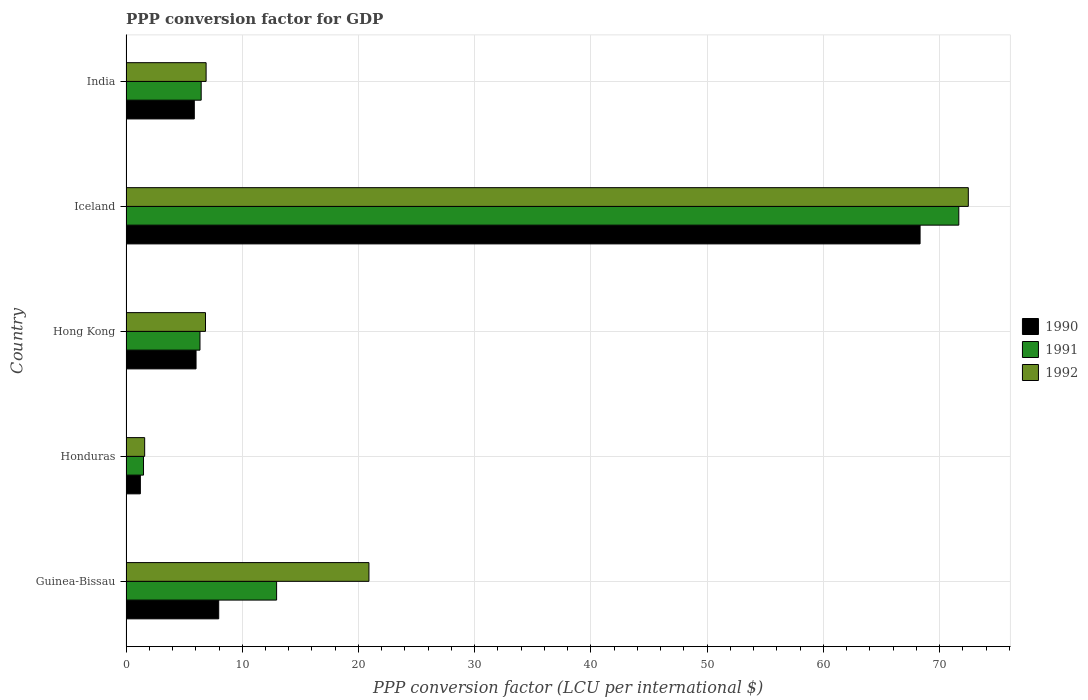How many groups of bars are there?
Provide a succinct answer. 5. Are the number of bars on each tick of the Y-axis equal?
Keep it short and to the point. Yes. What is the label of the 2nd group of bars from the top?
Your answer should be very brief. Iceland. In how many cases, is the number of bars for a given country not equal to the number of legend labels?
Your answer should be compact. 0. What is the PPP conversion factor for GDP in 1990 in Honduras?
Keep it short and to the point. 1.23. Across all countries, what is the maximum PPP conversion factor for GDP in 1991?
Offer a terse response. 71.65. Across all countries, what is the minimum PPP conversion factor for GDP in 1991?
Provide a succinct answer. 1.51. In which country was the PPP conversion factor for GDP in 1991 maximum?
Ensure brevity in your answer.  Iceland. In which country was the PPP conversion factor for GDP in 1990 minimum?
Provide a succinct answer. Honduras. What is the total PPP conversion factor for GDP in 1991 in the graph?
Offer a very short reply. 98.95. What is the difference between the PPP conversion factor for GDP in 1990 in Guinea-Bissau and that in Hong Kong?
Offer a terse response. 1.95. What is the difference between the PPP conversion factor for GDP in 1990 in Hong Kong and the PPP conversion factor for GDP in 1991 in Guinea-Bissau?
Your response must be concise. -6.93. What is the average PPP conversion factor for GDP in 1990 per country?
Offer a terse response. 17.89. What is the difference between the PPP conversion factor for GDP in 1990 and PPP conversion factor for GDP in 1991 in Iceland?
Keep it short and to the point. -3.33. What is the ratio of the PPP conversion factor for GDP in 1992 in Hong Kong to that in Iceland?
Give a very brief answer. 0.09. Is the PPP conversion factor for GDP in 1990 in Hong Kong less than that in India?
Give a very brief answer. No. Is the difference between the PPP conversion factor for GDP in 1990 in Guinea-Bissau and Honduras greater than the difference between the PPP conversion factor for GDP in 1991 in Guinea-Bissau and Honduras?
Ensure brevity in your answer.  No. What is the difference between the highest and the second highest PPP conversion factor for GDP in 1992?
Ensure brevity in your answer.  51.57. What is the difference between the highest and the lowest PPP conversion factor for GDP in 1990?
Keep it short and to the point. 67.09. In how many countries, is the PPP conversion factor for GDP in 1991 greater than the average PPP conversion factor for GDP in 1991 taken over all countries?
Provide a short and direct response. 1. What does the 2nd bar from the top in Hong Kong represents?
Your answer should be very brief. 1991. What does the 2nd bar from the bottom in Guinea-Bissau represents?
Your answer should be compact. 1991. Is it the case that in every country, the sum of the PPP conversion factor for GDP in 1991 and PPP conversion factor for GDP in 1992 is greater than the PPP conversion factor for GDP in 1990?
Ensure brevity in your answer.  Yes. How many legend labels are there?
Offer a very short reply. 3. How are the legend labels stacked?
Your answer should be very brief. Vertical. What is the title of the graph?
Offer a very short reply. PPP conversion factor for GDP. Does "1989" appear as one of the legend labels in the graph?
Ensure brevity in your answer.  No. What is the label or title of the X-axis?
Offer a very short reply. PPP conversion factor (LCU per international $). What is the PPP conversion factor (LCU per international $) in 1990 in Guinea-Bissau?
Your answer should be compact. 7.97. What is the PPP conversion factor (LCU per international $) of 1991 in Guinea-Bissau?
Offer a terse response. 12.96. What is the PPP conversion factor (LCU per international $) of 1992 in Guinea-Bissau?
Your response must be concise. 20.9. What is the PPP conversion factor (LCU per international $) of 1990 in Honduras?
Offer a terse response. 1.23. What is the PPP conversion factor (LCU per international $) in 1991 in Honduras?
Offer a very short reply. 1.51. What is the PPP conversion factor (LCU per international $) of 1992 in Honduras?
Your response must be concise. 1.61. What is the PPP conversion factor (LCU per international $) of 1990 in Hong Kong?
Give a very brief answer. 6.03. What is the PPP conversion factor (LCU per international $) of 1991 in Hong Kong?
Offer a terse response. 6.36. What is the PPP conversion factor (LCU per international $) in 1992 in Hong Kong?
Ensure brevity in your answer.  6.84. What is the PPP conversion factor (LCU per international $) in 1990 in Iceland?
Provide a succinct answer. 68.32. What is the PPP conversion factor (LCU per international $) of 1991 in Iceland?
Make the answer very short. 71.65. What is the PPP conversion factor (LCU per international $) of 1992 in Iceland?
Provide a short and direct response. 72.47. What is the PPP conversion factor (LCU per international $) in 1990 in India?
Offer a terse response. 5.88. What is the PPP conversion factor (LCU per international $) in 1991 in India?
Offer a terse response. 6.47. What is the PPP conversion factor (LCU per international $) of 1992 in India?
Give a very brief answer. 6.89. Across all countries, what is the maximum PPP conversion factor (LCU per international $) of 1990?
Offer a very short reply. 68.32. Across all countries, what is the maximum PPP conversion factor (LCU per international $) of 1991?
Offer a very short reply. 71.65. Across all countries, what is the maximum PPP conversion factor (LCU per international $) in 1992?
Offer a very short reply. 72.47. Across all countries, what is the minimum PPP conversion factor (LCU per international $) in 1990?
Keep it short and to the point. 1.23. Across all countries, what is the minimum PPP conversion factor (LCU per international $) of 1991?
Keep it short and to the point. 1.51. Across all countries, what is the minimum PPP conversion factor (LCU per international $) of 1992?
Keep it short and to the point. 1.61. What is the total PPP conversion factor (LCU per international $) in 1990 in the graph?
Keep it short and to the point. 89.43. What is the total PPP conversion factor (LCU per international $) in 1991 in the graph?
Provide a succinct answer. 98.95. What is the total PPP conversion factor (LCU per international $) in 1992 in the graph?
Your response must be concise. 108.71. What is the difference between the PPP conversion factor (LCU per international $) of 1990 in Guinea-Bissau and that in Honduras?
Keep it short and to the point. 6.74. What is the difference between the PPP conversion factor (LCU per international $) of 1991 in Guinea-Bissau and that in Honduras?
Your answer should be very brief. 11.45. What is the difference between the PPP conversion factor (LCU per international $) in 1992 in Guinea-Bissau and that in Honduras?
Give a very brief answer. 19.3. What is the difference between the PPP conversion factor (LCU per international $) of 1990 in Guinea-Bissau and that in Hong Kong?
Provide a succinct answer. 1.95. What is the difference between the PPP conversion factor (LCU per international $) of 1991 in Guinea-Bissau and that in Hong Kong?
Keep it short and to the point. 6.59. What is the difference between the PPP conversion factor (LCU per international $) in 1992 in Guinea-Bissau and that in Hong Kong?
Make the answer very short. 14.06. What is the difference between the PPP conversion factor (LCU per international $) of 1990 in Guinea-Bissau and that in Iceland?
Make the answer very short. -60.35. What is the difference between the PPP conversion factor (LCU per international $) of 1991 in Guinea-Bissau and that in Iceland?
Ensure brevity in your answer.  -58.69. What is the difference between the PPP conversion factor (LCU per international $) of 1992 in Guinea-Bissau and that in Iceland?
Your response must be concise. -51.57. What is the difference between the PPP conversion factor (LCU per international $) of 1990 in Guinea-Bissau and that in India?
Your response must be concise. 2.1. What is the difference between the PPP conversion factor (LCU per international $) of 1991 in Guinea-Bissau and that in India?
Offer a very short reply. 6.49. What is the difference between the PPP conversion factor (LCU per international $) of 1992 in Guinea-Bissau and that in India?
Offer a terse response. 14.01. What is the difference between the PPP conversion factor (LCU per international $) in 1990 in Honduras and that in Hong Kong?
Provide a short and direct response. -4.79. What is the difference between the PPP conversion factor (LCU per international $) in 1991 in Honduras and that in Hong Kong?
Your response must be concise. -4.86. What is the difference between the PPP conversion factor (LCU per international $) in 1992 in Honduras and that in Hong Kong?
Offer a terse response. -5.23. What is the difference between the PPP conversion factor (LCU per international $) in 1990 in Honduras and that in Iceland?
Provide a succinct answer. -67.09. What is the difference between the PPP conversion factor (LCU per international $) of 1991 in Honduras and that in Iceland?
Your answer should be very brief. -70.15. What is the difference between the PPP conversion factor (LCU per international $) of 1992 in Honduras and that in Iceland?
Ensure brevity in your answer.  -70.86. What is the difference between the PPP conversion factor (LCU per international $) in 1990 in Honduras and that in India?
Make the answer very short. -4.64. What is the difference between the PPP conversion factor (LCU per international $) in 1991 in Honduras and that in India?
Offer a terse response. -4.96. What is the difference between the PPP conversion factor (LCU per international $) in 1992 in Honduras and that in India?
Your answer should be very brief. -5.29. What is the difference between the PPP conversion factor (LCU per international $) in 1990 in Hong Kong and that in Iceland?
Ensure brevity in your answer.  -62.3. What is the difference between the PPP conversion factor (LCU per international $) of 1991 in Hong Kong and that in Iceland?
Ensure brevity in your answer.  -65.29. What is the difference between the PPP conversion factor (LCU per international $) of 1992 in Hong Kong and that in Iceland?
Provide a succinct answer. -65.63. What is the difference between the PPP conversion factor (LCU per international $) of 1990 in Hong Kong and that in India?
Provide a succinct answer. 0.15. What is the difference between the PPP conversion factor (LCU per international $) of 1991 in Hong Kong and that in India?
Provide a short and direct response. -0.1. What is the difference between the PPP conversion factor (LCU per international $) in 1992 in Hong Kong and that in India?
Your answer should be compact. -0.05. What is the difference between the PPP conversion factor (LCU per international $) in 1990 in Iceland and that in India?
Your answer should be very brief. 62.45. What is the difference between the PPP conversion factor (LCU per international $) in 1991 in Iceland and that in India?
Give a very brief answer. 65.18. What is the difference between the PPP conversion factor (LCU per international $) in 1992 in Iceland and that in India?
Provide a short and direct response. 65.58. What is the difference between the PPP conversion factor (LCU per international $) of 1990 in Guinea-Bissau and the PPP conversion factor (LCU per international $) of 1991 in Honduras?
Offer a terse response. 6.47. What is the difference between the PPP conversion factor (LCU per international $) in 1990 in Guinea-Bissau and the PPP conversion factor (LCU per international $) in 1992 in Honduras?
Provide a short and direct response. 6.37. What is the difference between the PPP conversion factor (LCU per international $) of 1991 in Guinea-Bissau and the PPP conversion factor (LCU per international $) of 1992 in Honduras?
Offer a very short reply. 11.35. What is the difference between the PPP conversion factor (LCU per international $) in 1990 in Guinea-Bissau and the PPP conversion factor (LCU per international $) in 1991 in Hong Kong?
Keep it short and to the point. 1.61. What is the difference between the PPP conversion factor (LCU per international $) in 1990 in Guinea-Bissau and the PPP conversion factor (LCU per international $) in 1992 in Hong Kong?
Offer a very short reply. 1.14. What is the difference between the PPP conversion factor (LCU per international $) in 1991 in Guinea-Bissau and the PPP conversion factor (LCU per international $) in 1992 in Hong Kong?
Offer a terse response. 6.12. What is the difference between the PPP conversion factor (LCU per international $) of 1990 in Guinea-Bissau and the PPP conversion factor (LCU per international $) of 1991 in Iceland?
Give a very brief answer. -63.68. What is the difference between the PPP conversion factor (LCU per international $) in 1990 in Guinea-Bissau and the PPP conversion factor (LCU per international $) in 1992 in Iceland?
Offer a very short reply. -64.5. What is the difference between the PPP conversion factor (LCU per international $) in 1991 in Guinea-Bissau and the PPP conversion factor (LCU per international $) in 1992 in Iceland?
Ensure brevity in your answer.  -59.51. What is the difference between the PPP conversion factor (LCU per international $) of 1990 in Guinea-Bissau and the PPP conversion factor (LCU per international $) of 1991 in India?
Offer a terse response. 1.51. What is the difference between the PPP conversion factor (LCU per international $) in 1990 in Guinea-Bissau and the PPP conversion factor (LCU per international $) in 1992 in India?
Offer a very short reply. 1.08. What is the difference between the PPP conversion factor (LCU per international $) of 1991 in Guinea-Bissau and the PPP conversion factor (LCU per international $) of 1992 in India?
Your response must be concise. 6.07. What is the difference between the PPP conversion factor (LCU per international $) in 1990 in Honduras and the PPP conversion factor (LCU per international $) in 1991 in Hong Kong?
Keep it short and to the point. -5.13. What is the difference between the PPP conversion factor (LCU per international $) of 1990 in Honduras and the PPP conversion factor (LCU per international $) of 1992 in Hong Kong?
Give a very brief answer. -5.6. What is the difference between the PPP conversion factor (LCU per international $) in 1991 in Honduras and the PPP conversion factor (LCU per international $) in 1992 in Hong Kong?
Your response must be concise. -5.33. What is the difference between the PPP conversion factor (LCU per international $) of 1990 in Honduras and the PPP conversion factor (LCU per international $) of 1991 in Iceland?
Make the answer very short. -70.42. What is the difference between the PPP conversion factor (LCU per international $) in 1990 in Honduras and the PPP conversion factor (LCU per international $) in 1992 in Iceland?
Your response must be concise. -71.24. What is the difference between the PPP conversion factor (LCU per international $) in 1991 in Honduras and the PPP conversion factor (LCU per international $) in 1992 in Iceland?
Provide a succinct answer. -70.97. What is the difference between the PPP conversion factor (LCU per international $) in 1990 in Honduras and the PPP conversion factor (LCU per international $) in 1991 in India?
Offer a terse response. -5.23. What is the difference between the PPP conversion factor (LCU per international $) of 1990 in Honduras and the PPP conversion factor (LCU per international $) of 1992 in India?
Offer a very short reply. -5.66. What is the difference between the PPP conversion factor (LCU per international $) in 1991 in Honduras and the PPP conversion factor (LCU per international $) in 1992 in India?
Your answer should be compact. -5.39. What is the difference between the PPP conversion factor (LCU per international $) of 1990 in Hong Kong and the PPP conversion factor (LCU per international $) of 1991 in Iceland?
Provide a succinct answer. -65.63. What is the difference between the PPP conversion factor (LCU per international $) of 1990 in Hong Kong and the PPP conversion factor (LCU per international $) of 1992 in Iceland?
Make the answer very short. -66.44. What is the difference between the PPP conversion factor (LCU per international $) of 1991 in Hong Kong and the PPP conversion factor (LCU per international $) of 1992 in Iceland?
Provide a short and direct response. -66.11. What is the difference between the PPP conversion factor (LCU per international $) of 1990 in Hong Kong and the PPP conversion factor (LCU per international $) of 1991 in India?
Offer a terse response. -0.44. What is the difference between the PPP conversion factor (LCU per international $) of 1990 in Hong Kong and the PPP conversion factor (LCU per international $) of 1992 in India?
Make the answer very short. -0.87. What is the difference between the PPP conversion factor (LCU per international $) of 1991 in Hong Kong and the PPP conversion factor (LCU per international $) of 1992 in India?
Give a very brief answer. -0.53. What is the difference between the PPP conversion factor (LCU per international $) of 1990 in Iceland and the PPP conversion factor (LCU per international $) of 1991 in India?
Ensure brevity in your answer.  61.85. What is the difference between the PPP conversion factor (LCU per international $) in 1990 in Iceland and the PPP conversion factor (LCU per international $) in 1992 in India?
Your answer should be very brief. 61.43. What is the difference between the PPP conversion factor (LCU per international $) of 1991 in Iceland and the PPP conversion factor (LCU per international $) of 1992 in India?
Give a very brief answer. 64.76. What is the average PPP conversion factor (LCU per international $) in 1990 per country?
Your response must be concise. 17.89. What is the average PPP conversion factor (LCU per international $) of 1991 per country?
Provide a short and direct response. 19.79. What is the average PPP conversion factor (LCU per international $) in 1992 per country?
Your answer should be compact. 21.74. What is the difference between the PPP conversion factor (LCU per international $) of 1990 and PPP conversion factor (LCU per international $) of 1991 in Guinea-Bissau?
Your response must be concise. -4.98. What is the difference between the PPP conversion factor (LCU per international $) of 1990 and PPP conversion factor (LCU per international $) of 1992 in Guinea-Bissau?
Make the answer very short. -12.93. What is the difference between the PPP conversion factor (LCU per international $) of 1991 and PPP conversion factor (LCU per international $) of 1992 in Guinea-Bissau?
Provide a succinct answer. -7.94. What is the difference between the PPP conversion factor (LCU per international $) in 1990 and PPP conversion factor (LCU per international $) in 1991 in Honduras?
Offer a very short reply. -0.27. What is the difference between the PPP conversion factor (LCU per international $) in 1990 and PPP conversion factor (LCU per international $) in 1992 in Honduras?
Provide a short and direct response. -0.37. What is the difference between the PPP conversion factor (LCU per international $) in 1991 and PPP conversion factor (LCU per international $) in 1992 in Honduras?
Give a very brief answer. -0.1. What is the difference between the PPP conversion factor (LCU per international $) of 1990 and PPP conversion factor (LCU per international $) of 1991 in Hong Kong?
Ensure brevity in your answer.  -0.34. What is the difference between the PPP conversion factor (LCU per international $) in 1990 and PPP conversion factor (LCU per international $) in 1992 in Hong Kong?
Keep it short and to the point. -0.81. What is the difference between the PPP conversion factor (LCU per international $) in 1991 and PPP conversion factor (LCU per international $) in 1992 in Hong Kong?
Your answer should be compact. -0.47. What is the difference between the PPP conversion factor (LCU per international $) in 1990 and PPP conversion factor (LCU per international $) in 1991 in Iceland?
Offer a terse response. -3.33. What is the difference between the PPP conversion factor (LCU per international $) in 1990 and PPP conversion factor (LCU per international $) in 1992 in Iceland?
Ensure brevity in your answer.  -4.15. What is the difference between the PPP conversion factor (LCU per international $) of 1991 and PPP conversion factor (LCU per international $) of 1992 in Iceland?
Offer a terse response. -0.82. What is the difference between the PPP conversion factor (LCU per international $) of 1990 and PPP conversion factor (LCU per international $) of 1991 in India?
Offer a very short reply. -0.59. What is the difference between the PPP conversion factor (LCU per international $) in 1990 and PPP conversion factor (LCU per international $) in 1992 in India?
Your answer should be compact. -1.02. What is the difference between the PPP conversion factor (LCU per international $) of 1991 and PPP conversion factor (LCU per international $) of 1992 in India?
Offer a very short reply. -0.42. What is the ratio of the PPP conversion factor (LCU per international $) of 1990 in Guinea-Bissau to that in Honduras?
Offer a very short reply. 6.46. What is the ratio of the PPP conversion factor (LCU per international $) in 1991 in Guinea-Bissau to that in Honduras?
Offer a terse response. 8.61. What is the ratio of the PPP conversion factor (LCU per international $) in 1992 in Guinea-Bissau to that in Honduras?
Keep it short and to the point. 13.02. What is the ratio of the PPP conversion factor (LCU per international $) in 1990 in Guinea-Bissau to that in Hong Kong?
Offer a terse response. 1.32. What is the ratio of the PPP conversion factor (LCU per international $) of 1991 in Guinea-Bissau to that in Hong Kong?
Your response must be concise. 2.04. What is the ratio of the PPP conversion factor (LCU per international $) of 1992 in Guinea-Bissau to that in Hong Kong?
Offer a very short reply. 3.06. What is the ratio of the PPP conversion factor (LCU per international $) in 1990 in Guinea-Bissau to that in Iceland?
Your answer should be compact. 0.12. What is the ratio of the PPP conversion factor (LCU per international $) of 1991 in Guinea-Bissau to that in Iceland?
Make the answer very short. 0.18. What is the ratio of the PPP conversion factor (LCU per international $) in 1992 in Guinea-Bissau to that in Iceland?
Offer a terse response. 0.29. What is the ratio of the PPP conversion factor (LCU per international $) in 1990 in Guinea-Bissau to that in India?
Your response must be concise. 1.36. What is the ratio of the PPP conversion factor (LCU per international $) in 1991 in Guinea-Bissau to that in India?
Ensure brevity in your answer.  2. What is the ratio of the PPP conversion factor (LCU per international $) of 1992 in Guinea-Bissau to that in India?
Make the answer very short. 3.03. What is the ratio of the PPP conversion factor (LCU per international $) in 1990 in Honduras to that in Hong Kong?
Provide a succinct answer. 0.2. What is the ratio of the PPP conversion factor (LCU per international $) in 1991 in Honduras to that in Hong Kong?
Provide a succinct answer. 0.24. What is the ratio of the PPP conversion factor (LCU per international $) of 1992 in Honduras to that in Hong Kong?
Provide a short and direct response. 0.23. What is the ratio of the PPP conversion factor (LCU per international $) of 1990 in Honduras to that in Iceland?
Offer a terse response. 0.02. What is the ratio of the PPP conversion factor (LCU per international $) in 1991 in Honduras to that in Iceland?
Make the answer very short. 0.02. What is the ratio of the PPP conversion factor (LCU per international $) of 1992 in Honduras to that in Iceland?
Your answer should be compact. 0.02. What is the ratio of the PPP conversion factor (LCU per international $) in 1990 in Honduras to that in India?
Ensure brevity in your answer.  0.21. What is the ratio of the PPP conversion factor (LCU per international $) of 1991 in Honduras to that in India?
Your response must be concise. 0.23. What is the ratio of the PPP conversion factor (LCU per international $) of 1992 in Honduras to that in India?
Offer a terse response. 0.23. What is the ratio of the PPP conversion factor (LCU per international $) in 1990 in Hong Kong to that in Iceland?
Offer a terse response. 0.09. What is the ratio of the PPP conversion factor (LCU per international $) in 1991 in Hong Kong to that in Iceland?
Offer a very short reply. 0.09. What is the ratio of the PPP conversion factor (LCU per international $) in 1992 in Hong Kong to that in Iceland?
Keep it short and to the point. 0.09. What is the ratio of the PPP conversion factor (LCU per international $) of 1990 in Hong Kong to that in India?
Your response must be concise. 1.03. What is the ratio of the PPP conversion factor (LCU per international $) in 1992 in Hong Kong to that in India?
Make the answer very short. 0.99. What is the ratio of the PPP conversion factor (LCU per international $) in 1990 in Iceland to that in India?
Provide a short and direct response. 11.63. What is the ratio of the PPP conversion factor (LCU per international $) of 1991 in Iceland to that in India?
Provide a succinct answer. 11.08. What is the ratio of the PPP conversion factor (LCU per international $) in 1992 in Iceland to that in India?
Ensure brevity in your answer.  10.52. What is the difference between the highest and the second highest PPP conversion factor (LCU per international $) of 1990?
Ensure brevity in your answer.  60.35. What is the difference between the highest and the second highest PPP conversion factor (LCU per international $) in 1991?
Keep it short and to the point. 58.69. What is the difference between the highest and the second highest PPP conversion factor (LCU per international $) in 1992?
Offer a very short reply. 51.57. What is the difference between the highest and the lowest PPP conversion factor (LCU per international $) in 1990?
Give a very brief answer. 67.09. What is the difference between the highest and the lowest PPP conversion factor (LCU per international $) in 1991?
Make the answer very short. 70.15. What is the difference between the highest and the lowest PPP conversion factor (LCU per international $) of 1992?
Keep it short and to the point. 70.86. 